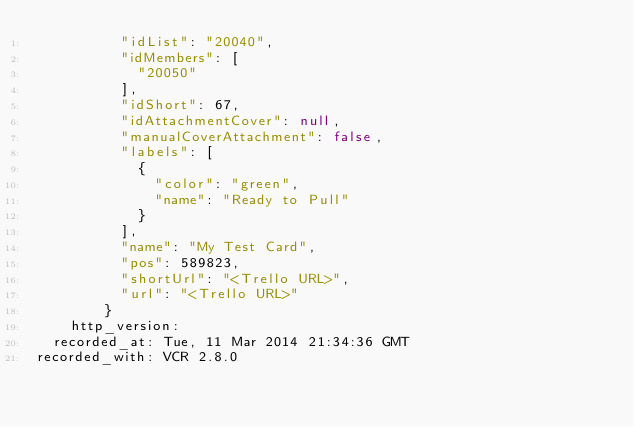Convert code to text. <code><loc_0><loc_0><loc_500><loc_500><_YAML_>          "idList": "20040",
          "idMembers": [
            "20050"
          ],
          "idShort": 67,
          "idAttachmentCover": null,
          "manualCoverAttachment": false,
          "labels": [
            {
              "color": "green",
              "name": "Ready to Pull"
            }
          ],
          "name": "My Test Card",
          "pos": 589823,
          "shortUrl": "<Trello URL>",
          "url": "<Trello URL>"
        }
    http_version: 
  recorded_at: Tue, 11 Mar 2014 21:34:36 GMT
recorded_with: VCR 2.8.0
</code> 